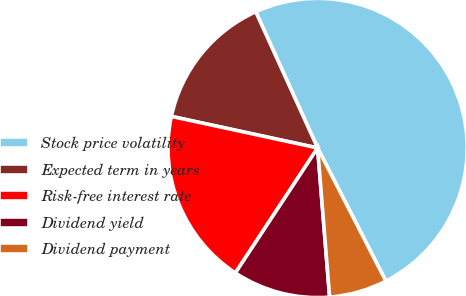<chart> <loc_0><loc_0><loc_500><loc_500><pie_chart><fcel>Stock price volatility<fcel>Expected term in years<fcel>Risk-free interest rate<fcel>Dividend yield<fcel>Dividend payment<nl><fcel>49.25%<fcel>14.83%<fcel>19.12%<fcel>10.54%<fcel>6.26%<nl></chart> 